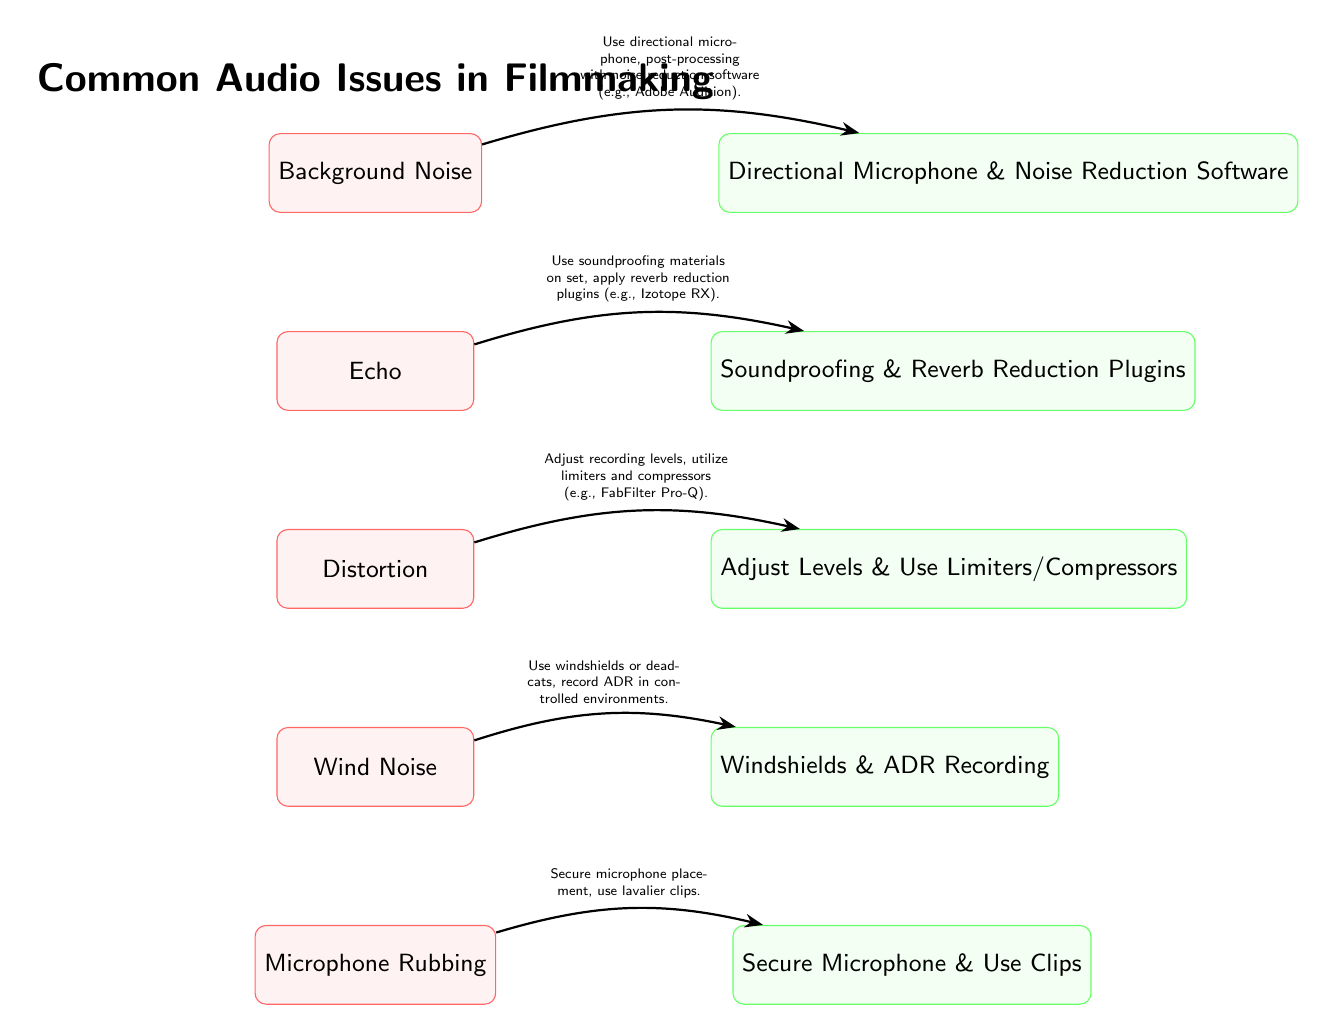What is the first audio issue listed in the diagram? The first audio issue listed in the diagram is found at the top node under the title "Common Audio Issues in Filmmaking". This issue is "Background Noise".
Answer: Background Noise How many audio issues are illustrated in the diagram? By counting the individual audio issue nodes stacked vertically, one can determine that there are five audio issues presented in the diagram.
Answer: Five What solution is suggested for "Distortion"? To find the suggested solution for "Distortion", one can follow the arrow leading from the "Distortion" issue node to its corresponding solution node, which clearly states it involves adjusting levels and using limiters/compressors.
Answer: Adjust Levels & Use Limiters/Compressors What relationship exists between "Echo" and "Reverb Reduction Plugins"? The relationship flows from the "Echo" issue node to the "Reverb Reduction Plugins" solution node through an arrow, indicating a direct link where the suggestion is to apply reverb reduction plugins to resolve the echo issue.
Answer: Use soundproofing materials on set, apply reverb reduction plugins What is the common action suggested for both "Wind Noise" and "Microphone Rubbing"? To find the common action, examine the solutions for both "Wind Noise" and "Microphone Rubbing". Both suggest enhancing secure handling or protection of the microphone, shown in the respective solution directives for each issue.
Answer: Secure Microphone & Use Clips 